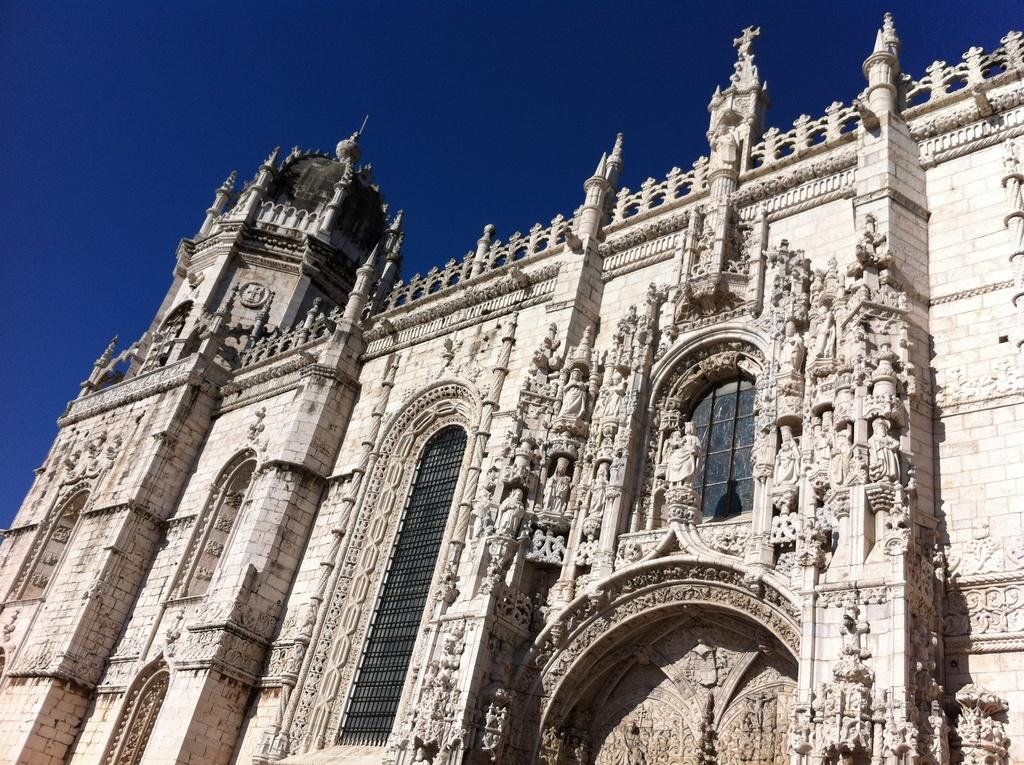What type of structure is present in the picture? There is a building in the picture. What can be seen in the background of the picture? The sky is visible at the top of the picture. Are there any openings in the building? Yes, there is a window in the building. What architectural feature is present on the building? There are grilles on the building. What type of treatment is being administered at the dock in the image? There is no dock or treatment present in the image; it only features a building with a window and grilles. 